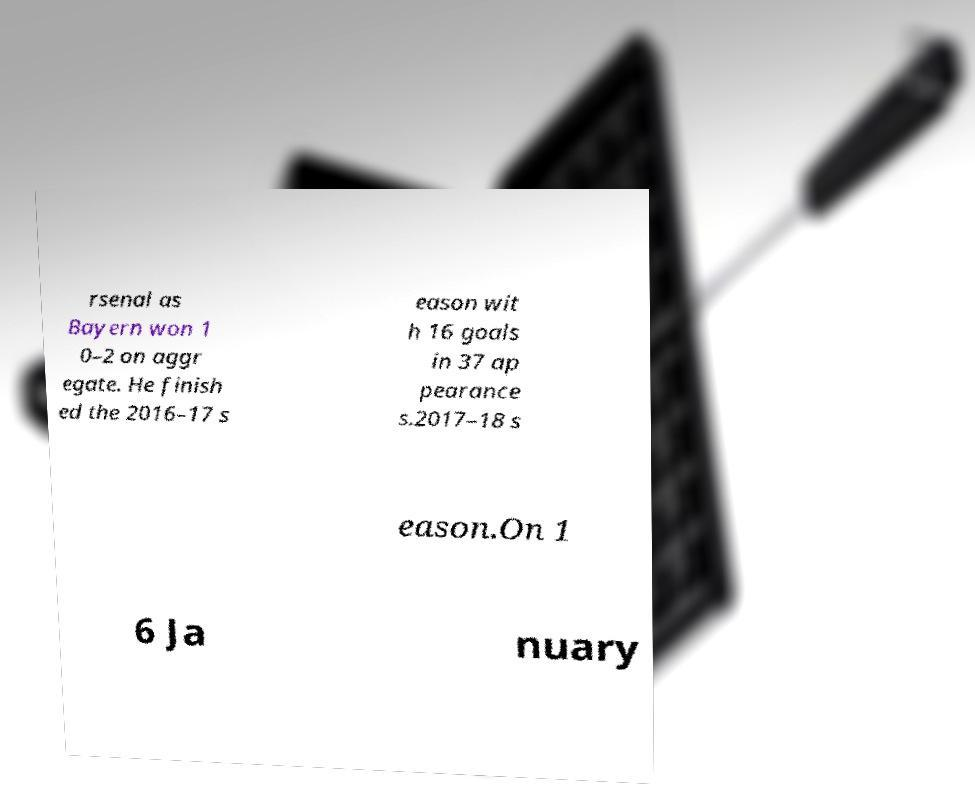Please read and relay the text visible in this image. What does it say? rsenal as Bayern won 1 0–2 on aggr egate. He finish ed the 2016–17 s eason wit h 16 goals in 37 ap pearance s.2017–18 s eason.On 1 6 Ja nuary 